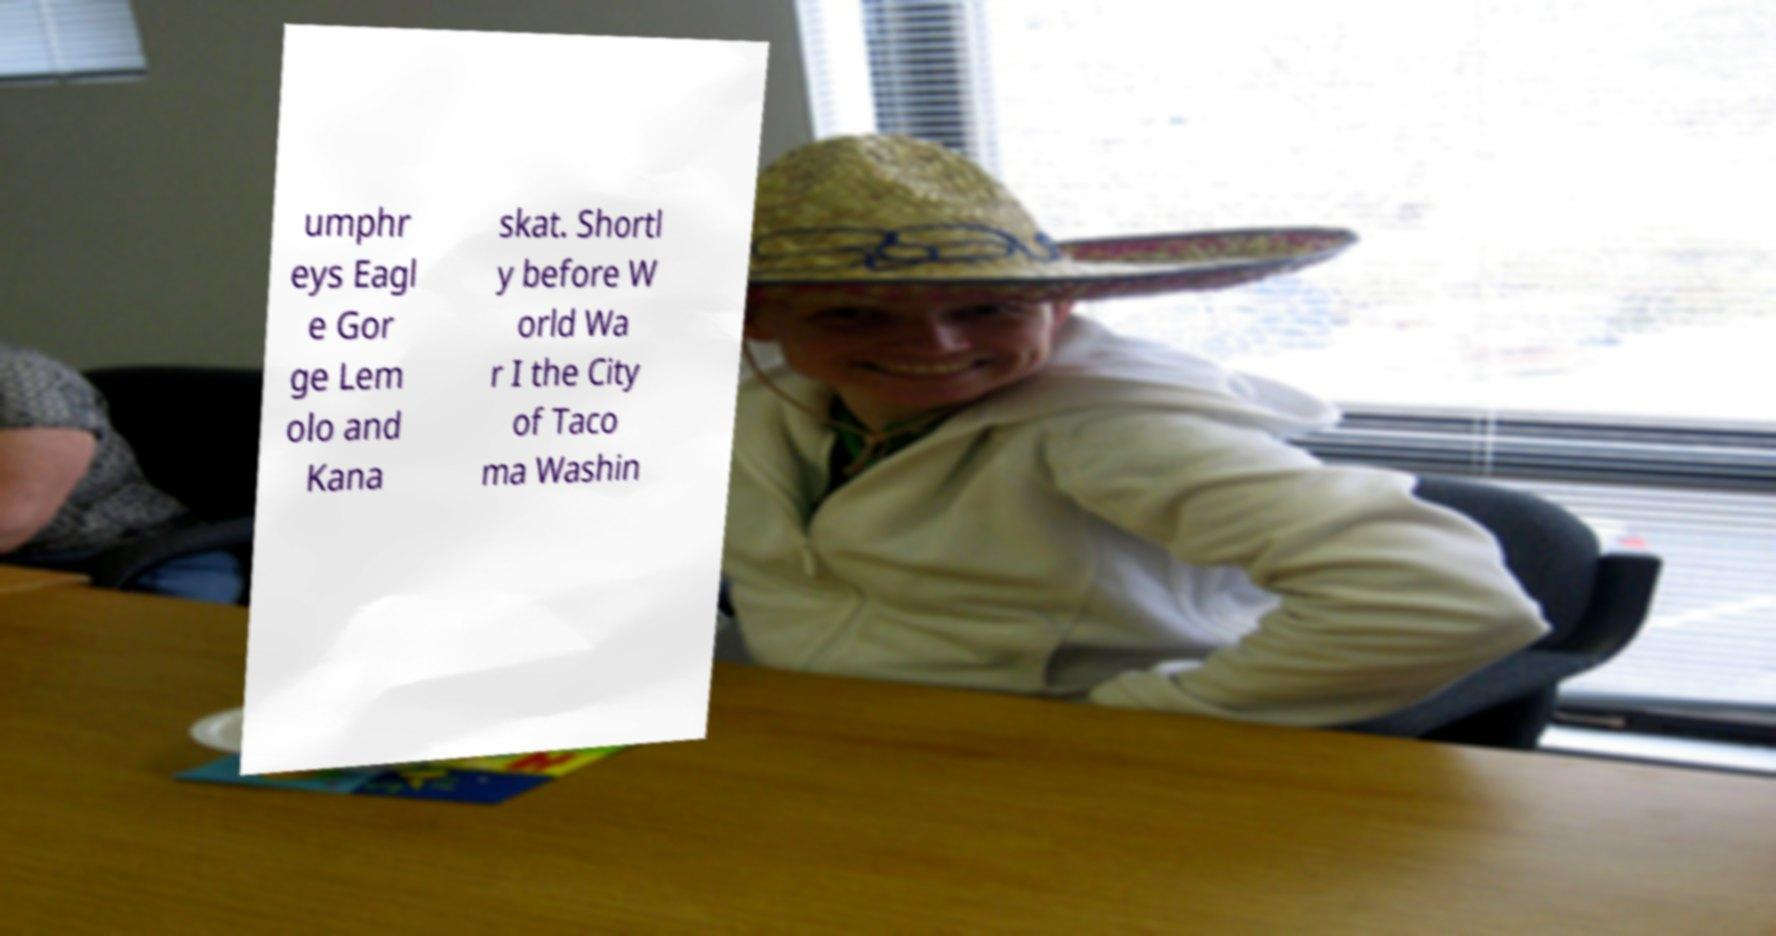Can you accurately transcribe the text from the provided image for me? umphr eys Eagl e Gor ge Lem olo and Kana skat. Shortl y before W orld Wa r I the City of Taco ma Washin 